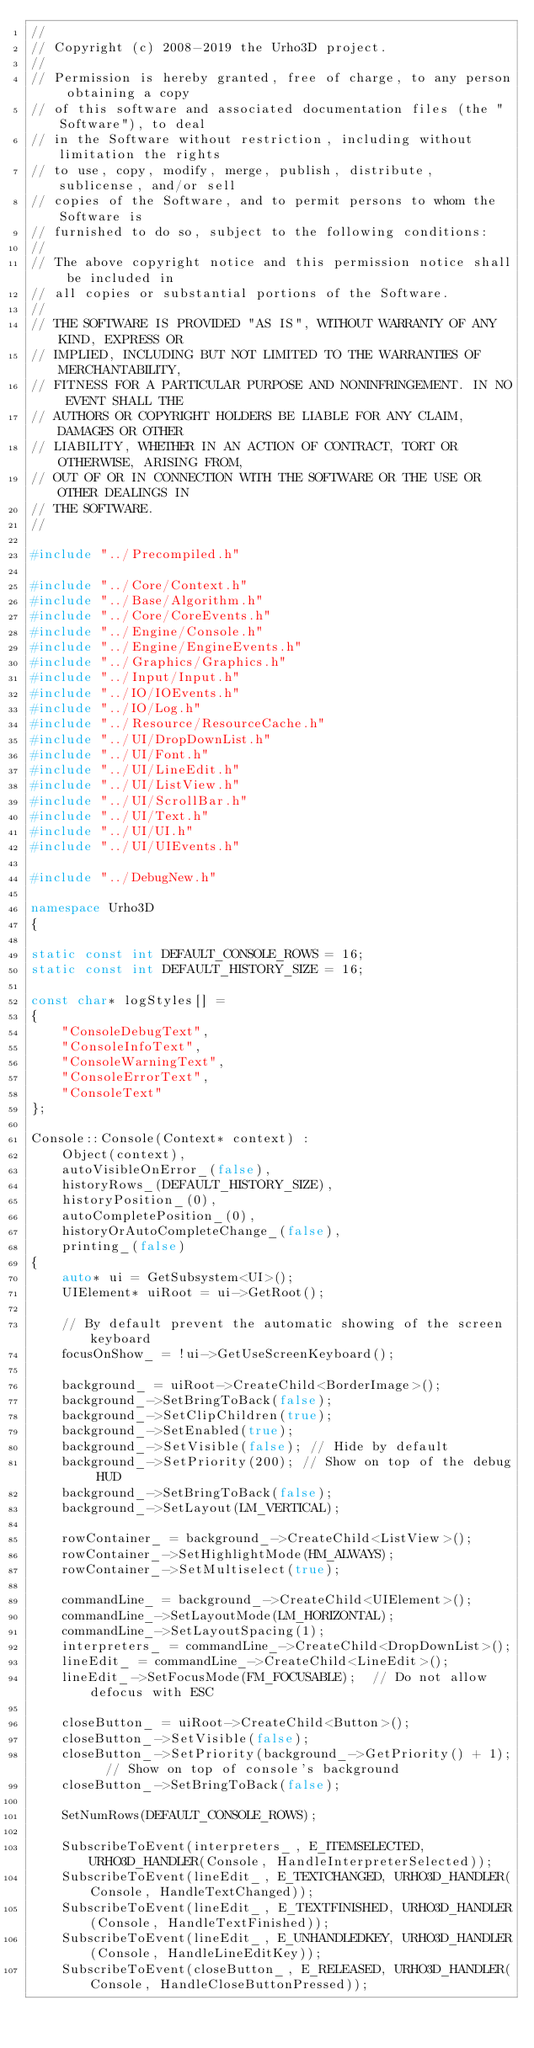<code> <loc_0><loc_0><loc_500><loc_500><_C++_>//
// Copyright (c) 2008-2019 the Urho3D project.
//
// Permission is hereby granted, free of charge, to any person obtaining a copy
// of this software and associated documentation files (the "Software"), to deal
// in the Software without restriction, including without limitation the rights
// to use, copy, modify, merge, publish, distribute, sublicense, and/or sell
// copies of the Software, and to permit persons to whom the Software is
// furnished to do so, subject to the following conditions:
//
// The above copyright notice and this permission notice shall be included in
// all copies or substantial portions of the Software.
//
// THE SOFTWARE IS PROVIDED "AS IS", WITHOUT WARRANTY OF ANY KIND, EXPRESS OR
// IMPLIED, INCLUDING BUT NOT LIMITED TO THE WARRANTIES OF MERCHANTABILITY,
// FITNESS FOR A PARTICULAR PURPOSE AND NONINFRINGEMENT. IN NO EVENT SHALL THE
// AUTHORS OR COPYRIGHT HOLDERS BE LIABLE FOR ANY CLAIM, DAMAGES OR OTHER
// LIABILITY, WHETHER IN AN ACTION OF CONTRACT, TORT OR OTHERWISE, ARISING FROM,
// OUT OF OR IN CONNECTION WITH THE SOFTWARE OR THE USE OR OTHER DEALINGS IN
// THE SOFTWARE.
//

#include "../Precompiled.h"

#include "../Core/Context.h"
#include "../Base/Algorithm.h"
#include "../Core/CoreEvents.h"
#include "../Engine/Console.h"
#include "../Engine/EngineEvents.h"
#include "../Graphics/Graphics.h"
#include "../Input/Input.h"
#include "../IO/IOEvents.h"
#include "../IO/Log.h"
#include "../Resource/ResourceCache.h"
#include "../UI/DropDownList.h"
#include "../UI/Font.h"
#include "../UI/LineEdit.h"
#include "../UI/ListView.h"
#include "../UI/ScrollBar.h"
#include "../UI/Text.h"
#include "../UI/UI.h"
#include "../UI/UIEvents.h"

#include "../DebugNew.h"

namespace Urho3D
{

static const int DEFAULT_CONSOLE_ROWS = 16;
static const int DEFAULT_HISTORY_SIZE = 16;

const char* logStyles[] =
{
    "ConsoleDebugText",
    "ConsoleInfoText",
    "ConsoleWarningText",
    "ConsoleErrorText",
    "ConsoleText"
};

Console::Console(Context* context) :
    Object(context),
    autoVisibleOnError_(false),
    historyRows_(DEFAULT_HISTORY_SIZE),
    historyPosition_(0),
    autoCompletePosition_(0),
    historyOrAutoCompleteChange_(false),
    printing_(false)
{
    auto* ui = GetSubsystem<UI>();
    UIElement* uiRoot = ui->GetRoot();

    // By default prevent the automatic showing of the screen keyboard
    focusOnShow_ = !ui->GetUseScreenKeyboard();

    background_ = uiRoot->CreateChild<BorderImage>();
    background_->SetBringToBack(false);
    background_->SetClipChildren(true);
    background_->SetEnabled(true);
    background_->SetVisible(false); // Hide by default
    background_->SetPriority(200); // Show on top of the debug HUD
    background_->SetBringToBack(false);
    background_->SetLayout(LM_VERTICAL);

    rowContainer_ = background_->CreateChild<ListView>();
    rowContainer_->SetHighlightMode(HM_ALWAYS);
    rowContainer_->SetMultiselect(true);

    commandLine_ = background_->CreateChild<UIElement>();
    commandLine_->SetLayoutMode(LM_HORIZONTAL);
    commandLine_->SetLayoutSpacing(1);
    interpreters_ = commandLine_->CreateChild<DropDownList>();
    lineEdit_ = commandLine_->CreateChild<LineEdit>();
    lineEdit_->SetFocusMode(FM_FOCUSABLE);  // Do not allow defocus with ESC

    closeButton_ = uiRoot->CreateChild<Button>();
    closeButton_->SetVisible(false);
    closeButton_->SetPriority(background_->GetPriority() + 1);  // Show on top of console's background
    closeButton_->SetBringToBack(false);

    SetNumRows(DEFAULT_CONSOLE_ROWS);

    SubscribeToEvent(interpreters_, E_ITEMSELECTED, URHO3D_HANDLER(Console, HandleInterpreterSelected));
    SubscribeToEvent(lineEdit_, E_TEXTCHANGED, URHO3D_HANDLER(Console, HandleTextChanged));
    SubscribeToEvent(lineEdit_, E_TEXTFINISHED, URHO3D_HANDLER(Console, HandleTextFinished));
    SubscribeToEvent(lineEdit_, E_UNHANDLEDKEY, URHO3D_HANDLER(Console, HandleLineEditKey));
    SubscribeToEvent(closeButton_, E_RELEASED, URHO3D_HANDLER(Console, HandleCloseButtonPressed));</code> 